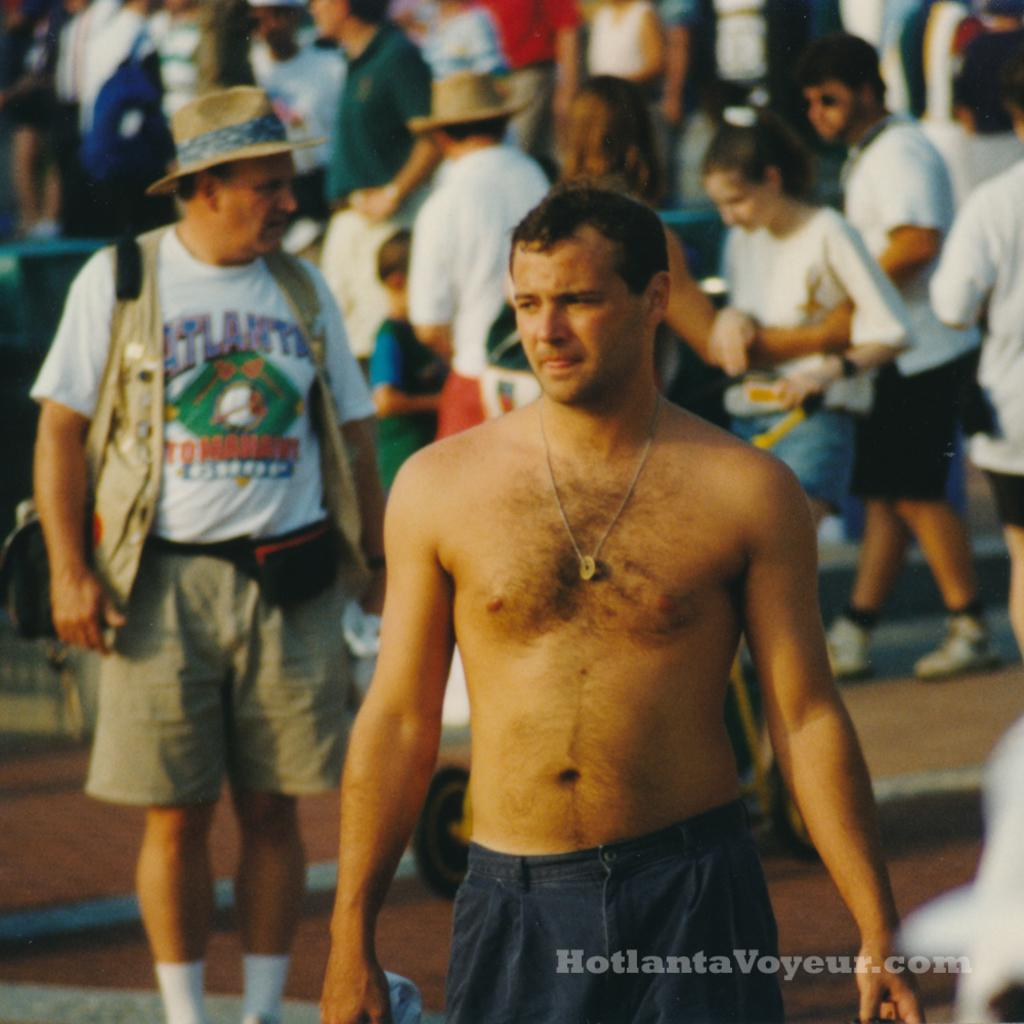<image>
Share a concise interpretation of the image provided. A group of people on a street with a man wearing a tshirt that says Atlanta. 